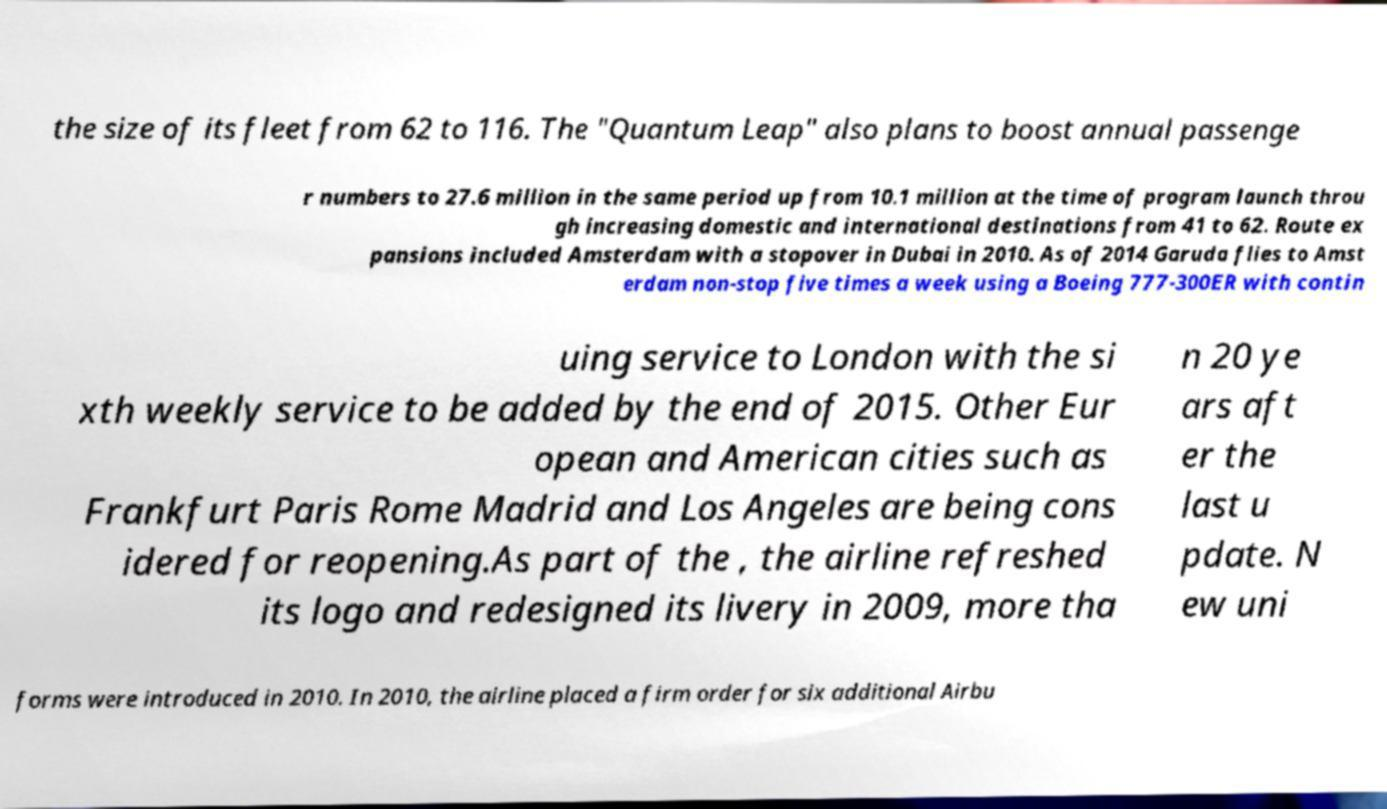What messages or text are displayed in this image? I need them in a readable, typed format. the size of its fleet from 62 to 116. The "Quantum Leap" also plans to boost annual passenge r numbers to 27.6 million in the same period up from 10.1 million at the time of program launch throu gh increasing domestic and international destinations from 41 to 62. Route ex pansions included Amsterdam with a stopover in Dubai in 2010. As of 2014 Garuda flies to Amst erdam non-stop five times a week using a Boeing 777-300ER with contin uing service to London with the si xth weekly service to be added by the end of 2015. Other Eur opean and American cities such as Frankfurt Paris Rome Madrid and Los Angeles are being cons idered for reopening.As part of the , the airline refreshed its logo and redesigned its livery in 2009, more tha n 20 ye ars aft er the last u pdate. N ew uni forms were introduced in 2010. In 2010, the airline placed a firm order for six additional Airbu 